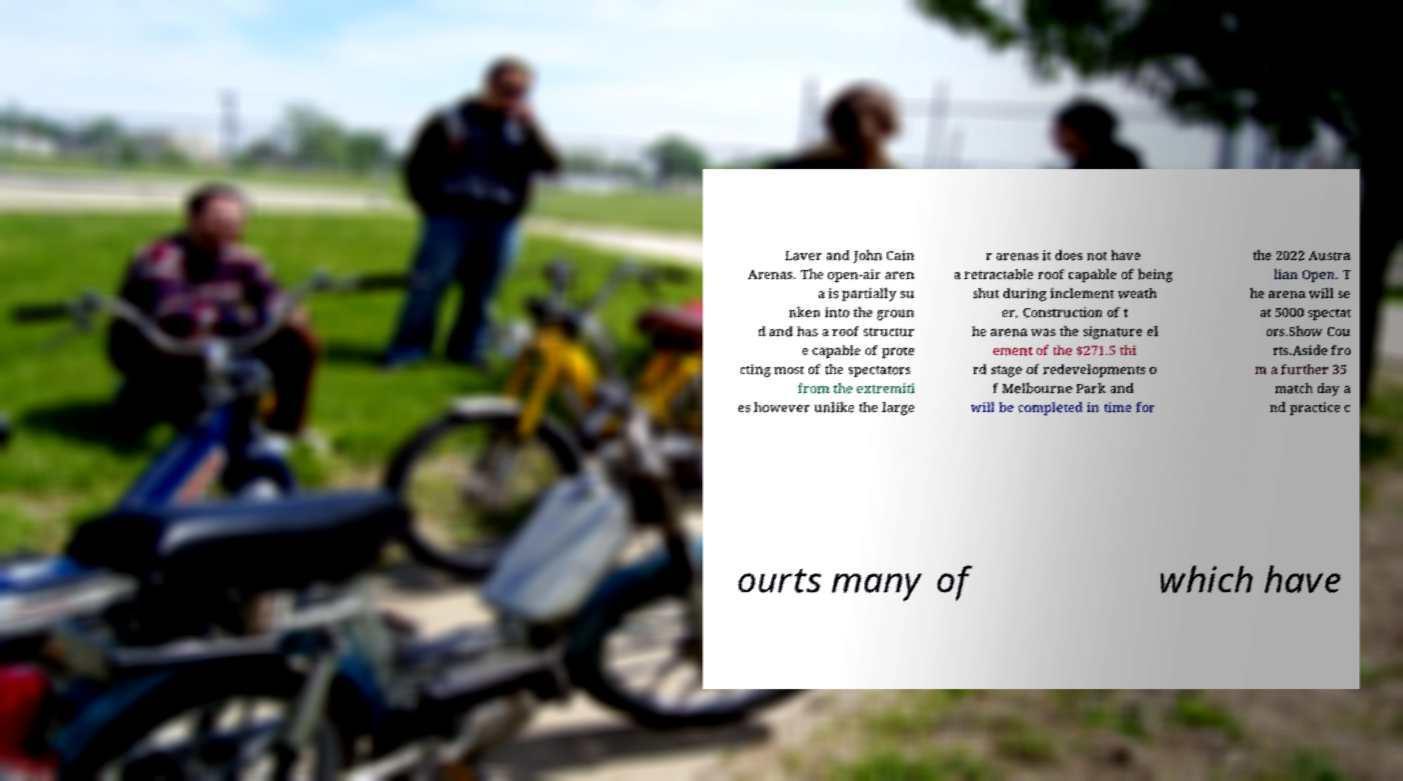There's text embedded in this image that I need extracted. Can you transcribe it verbatim? Laver and John Cain Arenas. The open-air aren a is partially su nken into the groun d and has a roof structur e capable of prote cting most of the spectators from the extremiti es however unlike the large r arenas it does not have a retractable roof capable of being shut during inclement weath er. Construction of t he arena was the signature el ement of the $271.5 thi rd stage of redevelopments o f Melbourne Park and will be completed in time for the 2022 Austra lian Open. T he arena will se at 5000 spectat ors.Show Cou rts.Aside fro m a further 35 match day a nd practice c ourts many of which have 